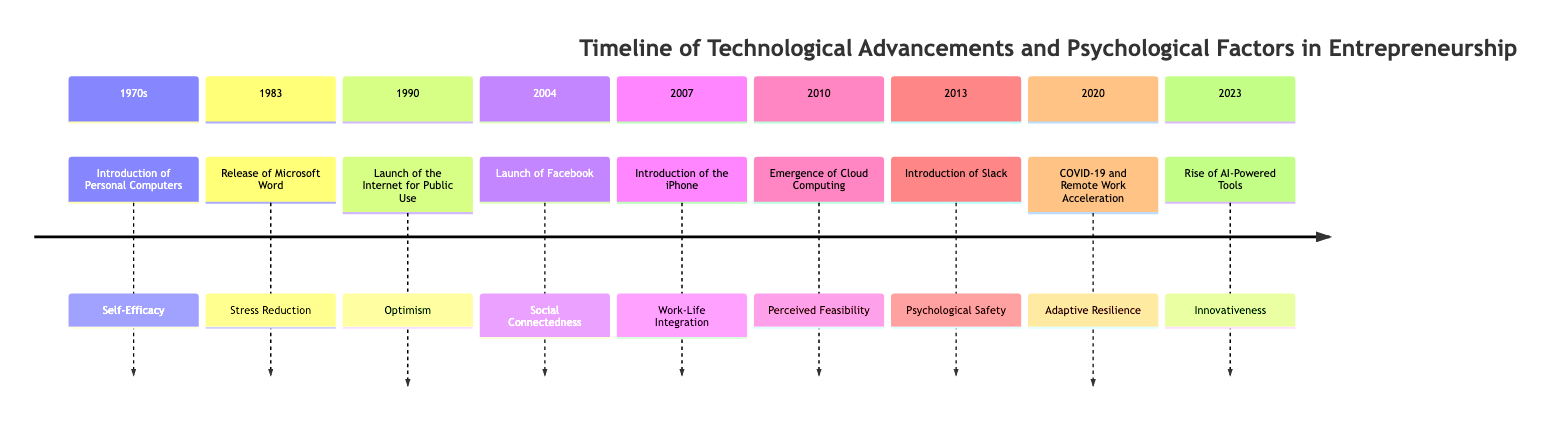What year was the introduction of personal computers? According to the timeline, the advent of personal computers occurred in the 1970s. This decade is the first entry in the timeline, indicating when this event took place.
Answer: 1970s What technological advancement occurred in 1990? The timeline lists the launch of the internet for public use as the significant event for the year 1990. This specific information can be found directly in the section corresponding to that year.
Answer: Launch of the Internet for Public Use Which psychological factor is associated with the release of Microsoft Word? The timeline indicates that the release of Microsoft Word in 1983 is associated with the psychological factor of stress reduction. This is directly stated in the description linked to that event.
Answer: Stress Reduction How many events are listed in the timeline? There are eight events detailed in the timeline, covering the years from the 1970s through 2023. A quick count of the distinct events listed confirms this number.
Answer: 8 What was the effect of the emergence of cloud computing in 2010? The event in 2010, which is the emergence of cloud computing, influenced stress reduction and perceived feasibility of entrepreneurial ventures. Both impacts are specified in relation to that event.
Answer: Stress Reduction, Perceived Feasibility Which technological advancement improved organizational communication in 2013? The timeline specifies that the introduction of Slack enhanced organizational communication among teams. This information is found in the section for that year, which directly states the effect of the tool.
Answer: Introduction of Slack What psychological factor increased as a result of COVID-19 in 2020? The timeline notes that adaptive resilience was significantly impacted by the pandemic-induced acceleration of remote work in 2020. This information is provided in the corresponding event description.
Answer: Adaptive Resilience What was a major benefit of the iPhone introduction for entrepreneurs? The advent of the iPhone in 2007 provided flexibility for entrepreneurs to manage their businesses on the go, which is directly highlighted in the timeline.
Answer: Flexibility 